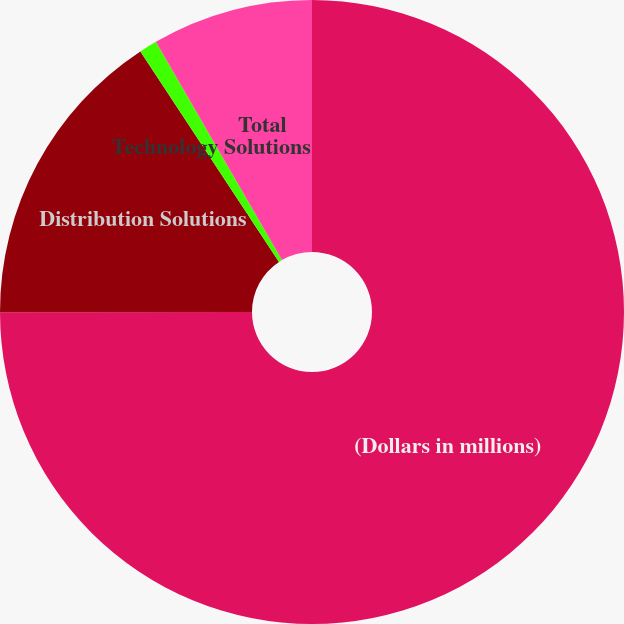Convert chart. <chart><loc_0><loc_0><loc_500><loc_500><pie_chart><fcel>(Dollars in millions)<fcel>Distribution Solutions<fcel>Technology Solutions<fcel>Total<nl><fcel>74.99%<fcel>15.74%<fcel>0.93%<fcel>8.34%<nl></chart> 